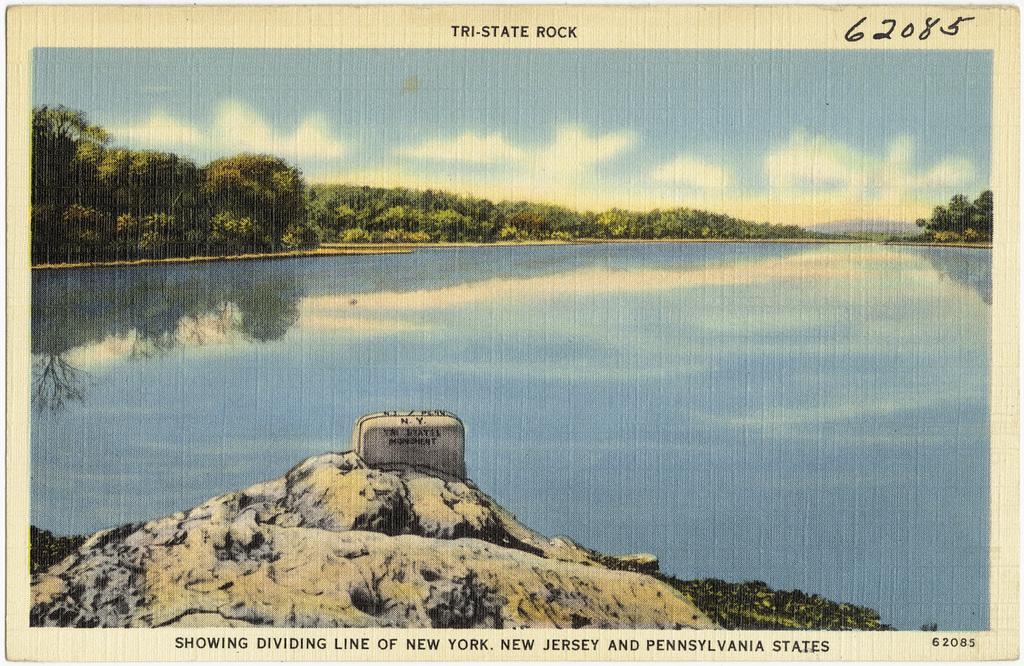Could you give a brief overview of what you see in this image? In the foreground of this poster, there is a rock and the grass. In the background, there is water, trees, sky and the cloud. 